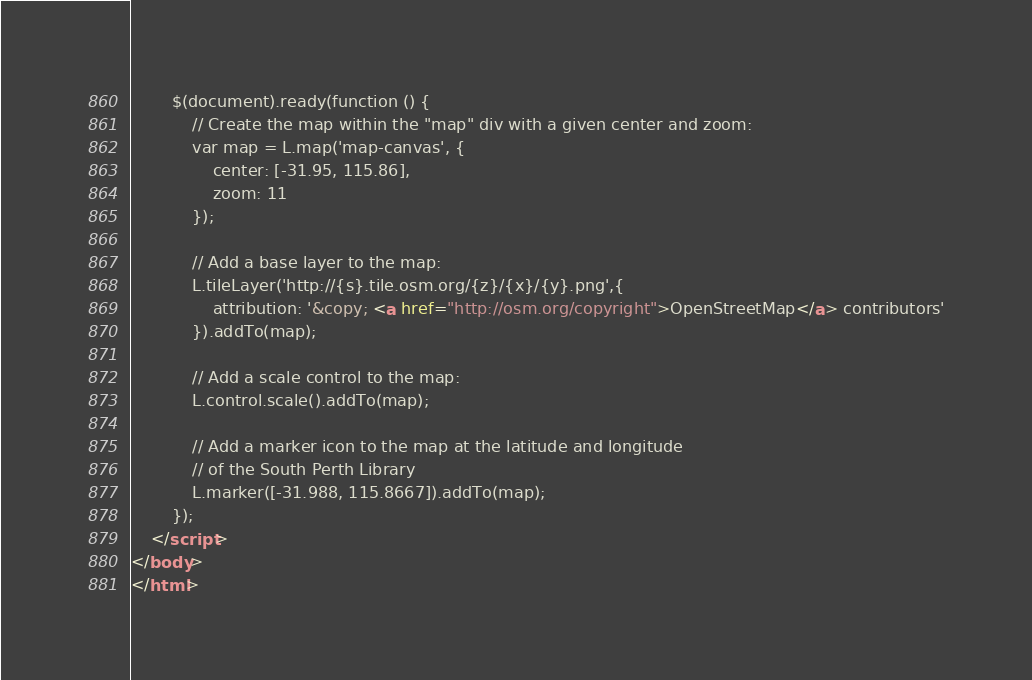<code> <loc_0><loc_0><loc_500><loc_500><_HTML_>        $(document).ready(function () {
            // Create the map within the "map" div with a given center and zoom:
            var map = L.map('map-canvas', {
                center: [-31.95, 115.86],
                zoom: 11
            });
            
            // Add a base layer to the map:
            L.tileLayer('http://{s}.tile.osm.org/{z}/{x}/{y}.png',{
                attribution: '&copy; <a href="http://osm.org/copyright">OpenStreetMap</a> contributors'
            }).addTo(map);

            // Add a scale control to the map:
            L.control.scale().addTo(map);

            // Add a marker icon to the map at the latitude and longitude
            // of the South Perth Library
            L.marker([-31.988, 115.8667]).addTo(map);
        });
    </script>
</body>
</html>
</code> 